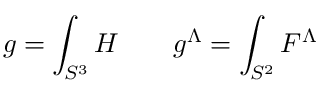<formula> <loc_0><loc_0><loc_500><loc_500>g = \int _ { S ^ { 3 } } H \quad g ^ { \Lambda } = \int _ { S ^ { 2 } } F ^ { \Lambda }</formula> 